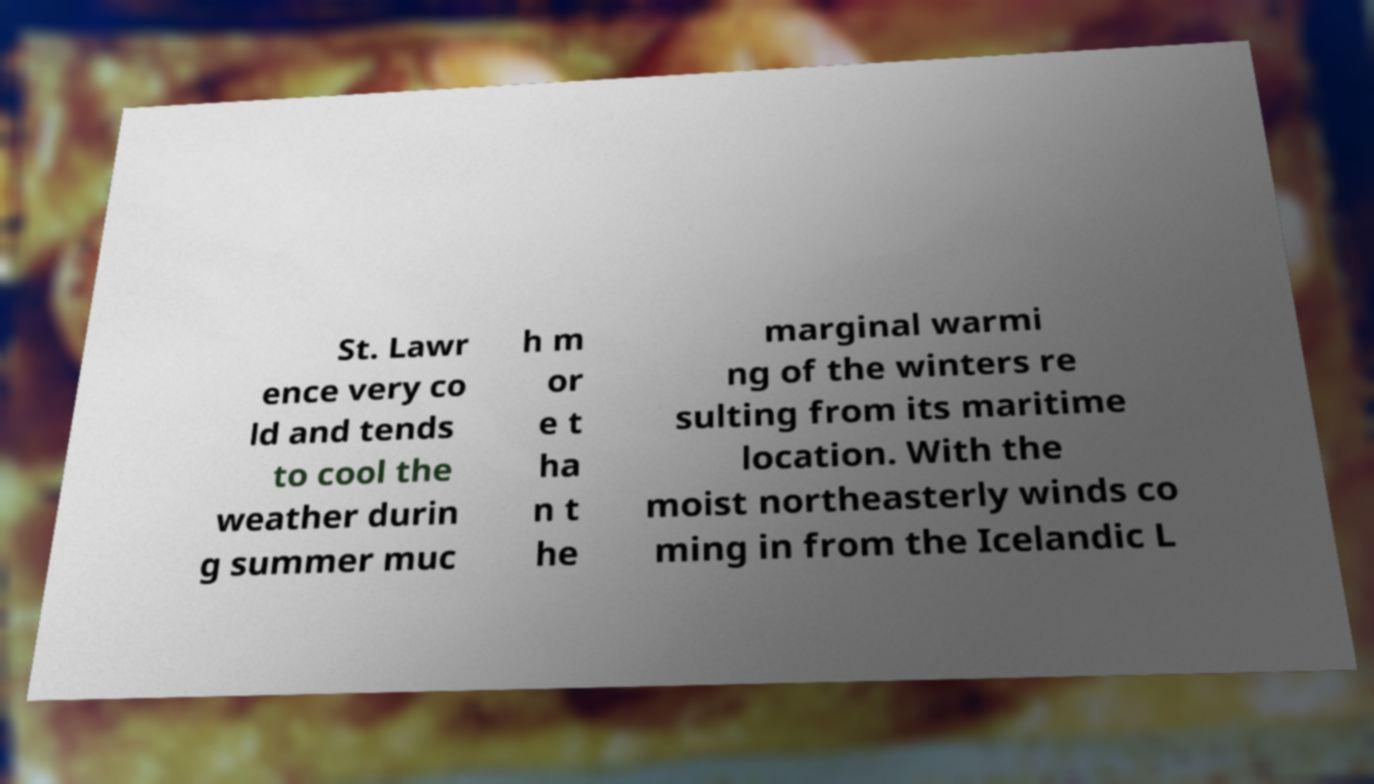Can you accurately transcribe the text from the provided image for me? St. Lawr ence very co ld and tends to cool the weather durin g summer muc h m or e t ha n t he marginal warmi ng of the winters re sulting from its maritime location. With the moist northeasterly winds co ming in from the Icelandic L 